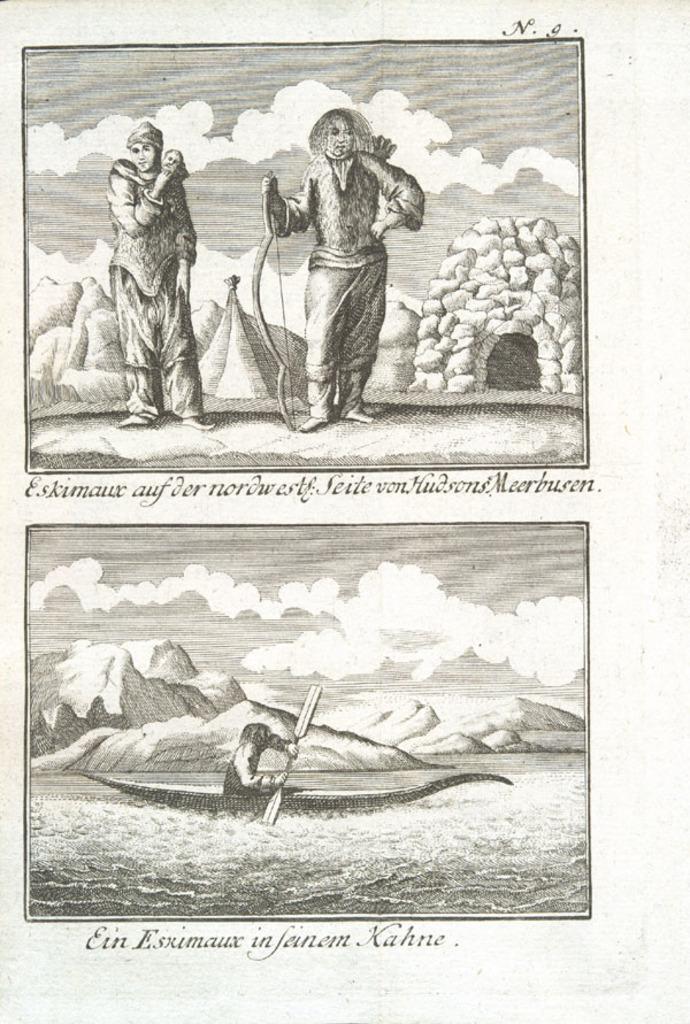Describe this image in one or two sentences. In this image we can see a poster with a few people, water, boat and the sky with clouds, also we can see the text on it. 